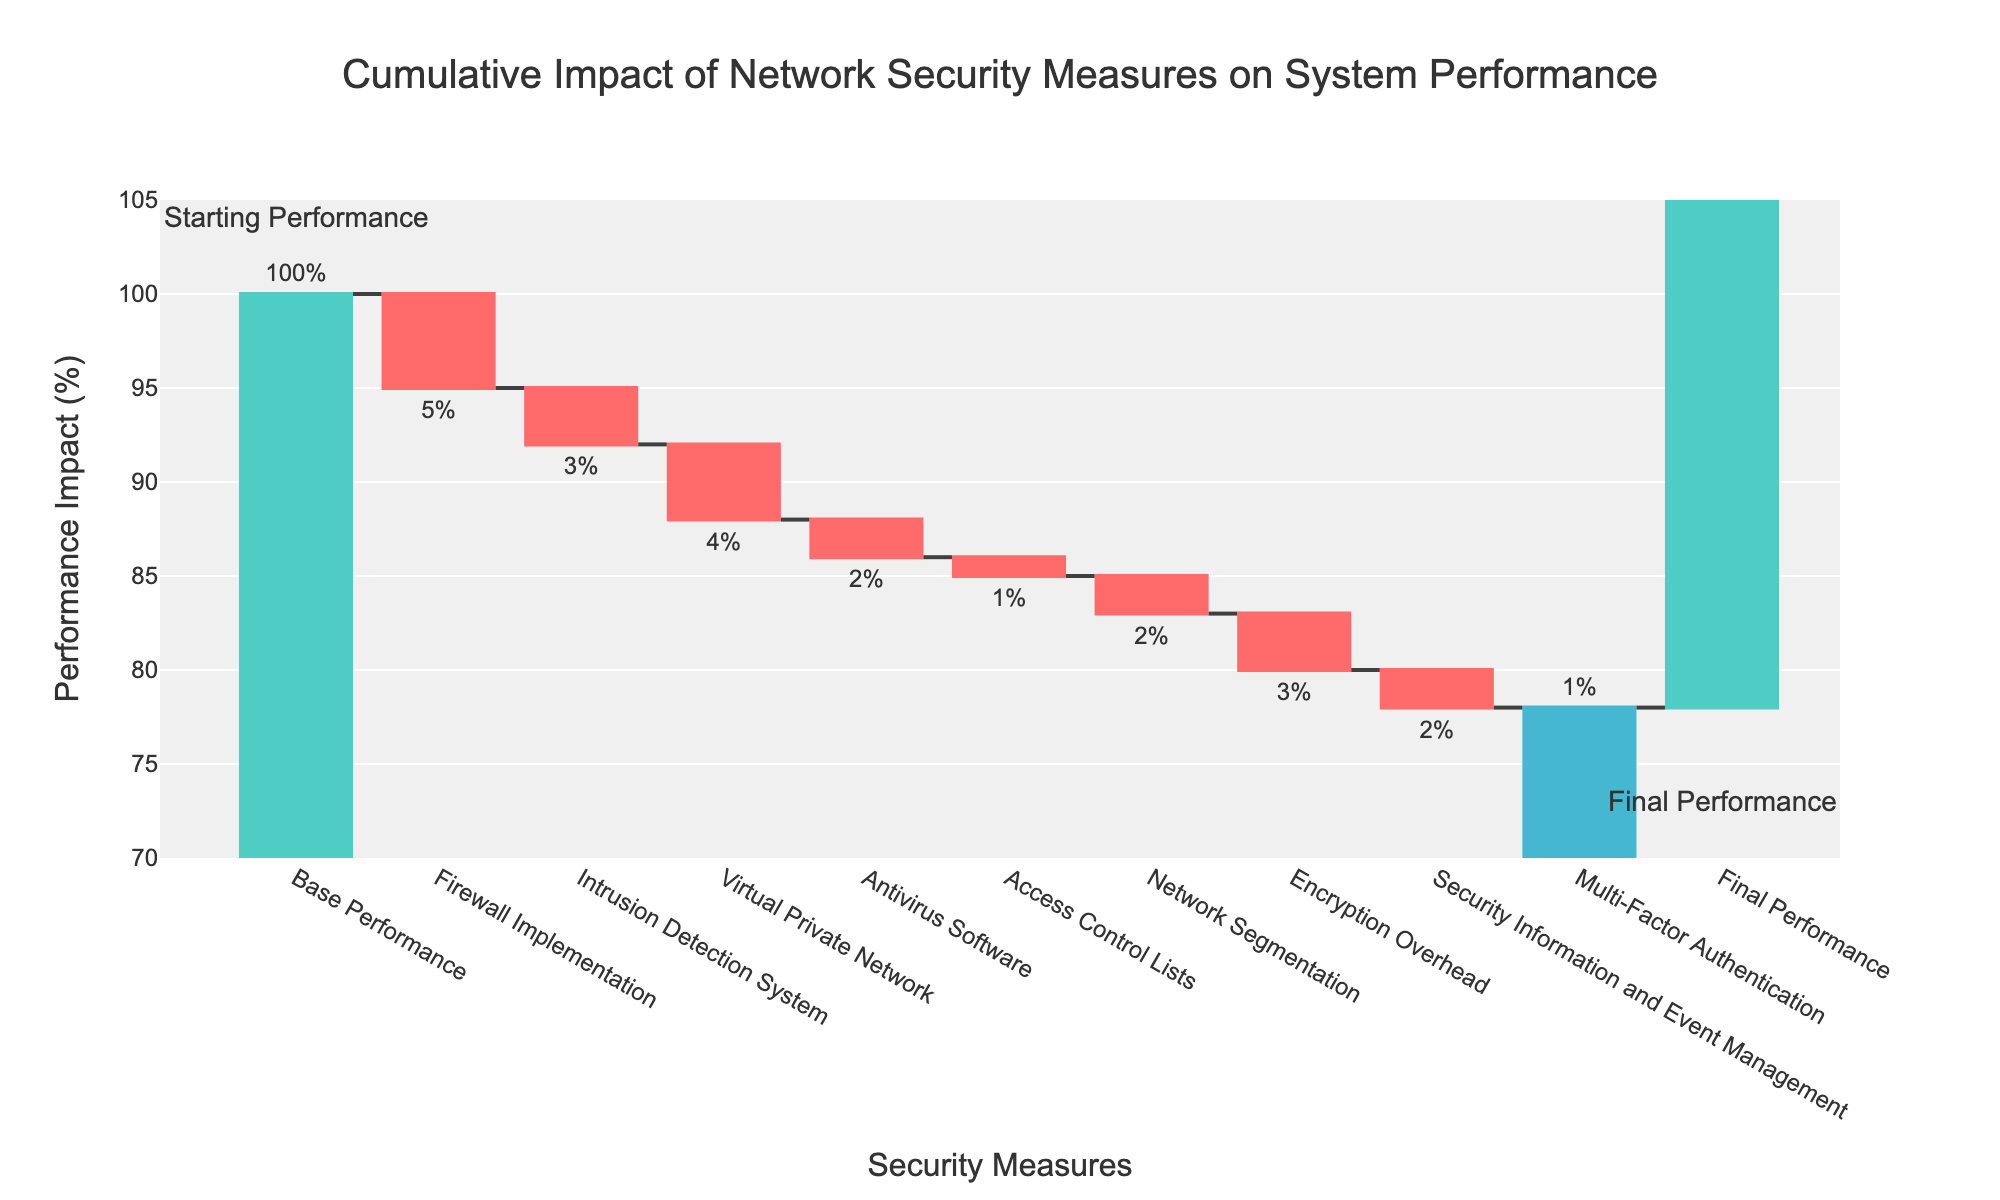What is the title of the chart? The title is displayed at the top of the chart, usually centered, and gives an overview of the chart's purpose. In this case, it's clearly visible.
Answer: "Cumulative Impact of Network Security Measures on System Performance" What is the initial performance value before security measures were implemented? The initial performance value is given as the first bar on the left of the chart with the label. It shows the starting point before any security measures are applied.
Answer: 100% What is the final performance value after all security measures were implemented? The final performance value is given as the last bar on the right of the chart with the label. It shows the ending point after all security measures have been applied.
Answer: 77% Which security measure had the largest negative impact on performance? Compare the lengths of the negative bars to determine the one that caused the largest drop. The measure with the most significant drop shows the greatest negative impact.
Answer: Firewall Implementation (-5%) What is the total performance impact of the Intrusion Detection System and Encryption Overhead combined? To get the combined impact, sum the negative values of the Intrusion Detection System and Encryption Overhead. The values are -3 and -3 respectively.
Answer: -6% By how much did performance decrease due to Antivirus Software compared to Access Control Lists? Subtract the performance impact of Access Control Lists from Antivirus Software. Antivirus Software impact is -2, Access Control Lists impact is -1.
Answer: -1% After which security measure did the performance drop to exactly 85%? To find when the performance hit 85%, start from 100% and subtract each measure's impact step by step until reaching 85%.
Answer: After Virtual Private Network What is the average negative impact of all the security measures on the performance? To find the average, sum all negative impacts and divide by the number of measures. Sum of impacts: -5, -3, -4, -2, -1, -2, -3, -2, -1 = -23. There are 9 measures. Average impact is -23/9.
Answer: -2.56% How much did the overall performance decrease from the base performance to the final performance? Subtract the final performance value from the base performance value. Base performance is 100, final is 77.
Answer: 23% Which security measure had the smallest impact on performance? Compare all bars representing the performance impacts of individual security measures and identify the smallest one.
Answer: Multi-Factor Authentication (-1%) 